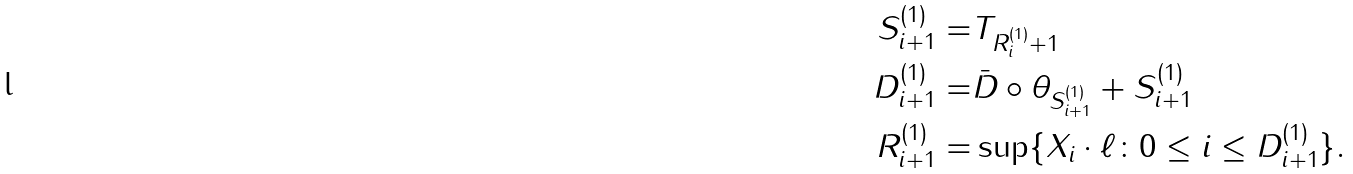Convert formula to latex. <formula><loc_0><loc_0><loc_500><loc_500>S ^ { ( 1 ) } _ { i + 1 } = & T _ { R ^ { ( 1 ) } _ { i } + 1 } \\ D ^ { ( 1 ) } _ { i + 1 } = & \bar { D } \circ \theta _ { S ^ { ( 1 ) } _ { i + 1 } } + S ^ { ( 1 ) } _ { i + 1 } \\ R ^ { ( 1 ) } _ { i + 1 } = & \sup \{ X _ { i } \cdot \ell \colon 0 \leq i \leq D ^ { ( 1 ) } _ { i + 1 } \} .</formula> 